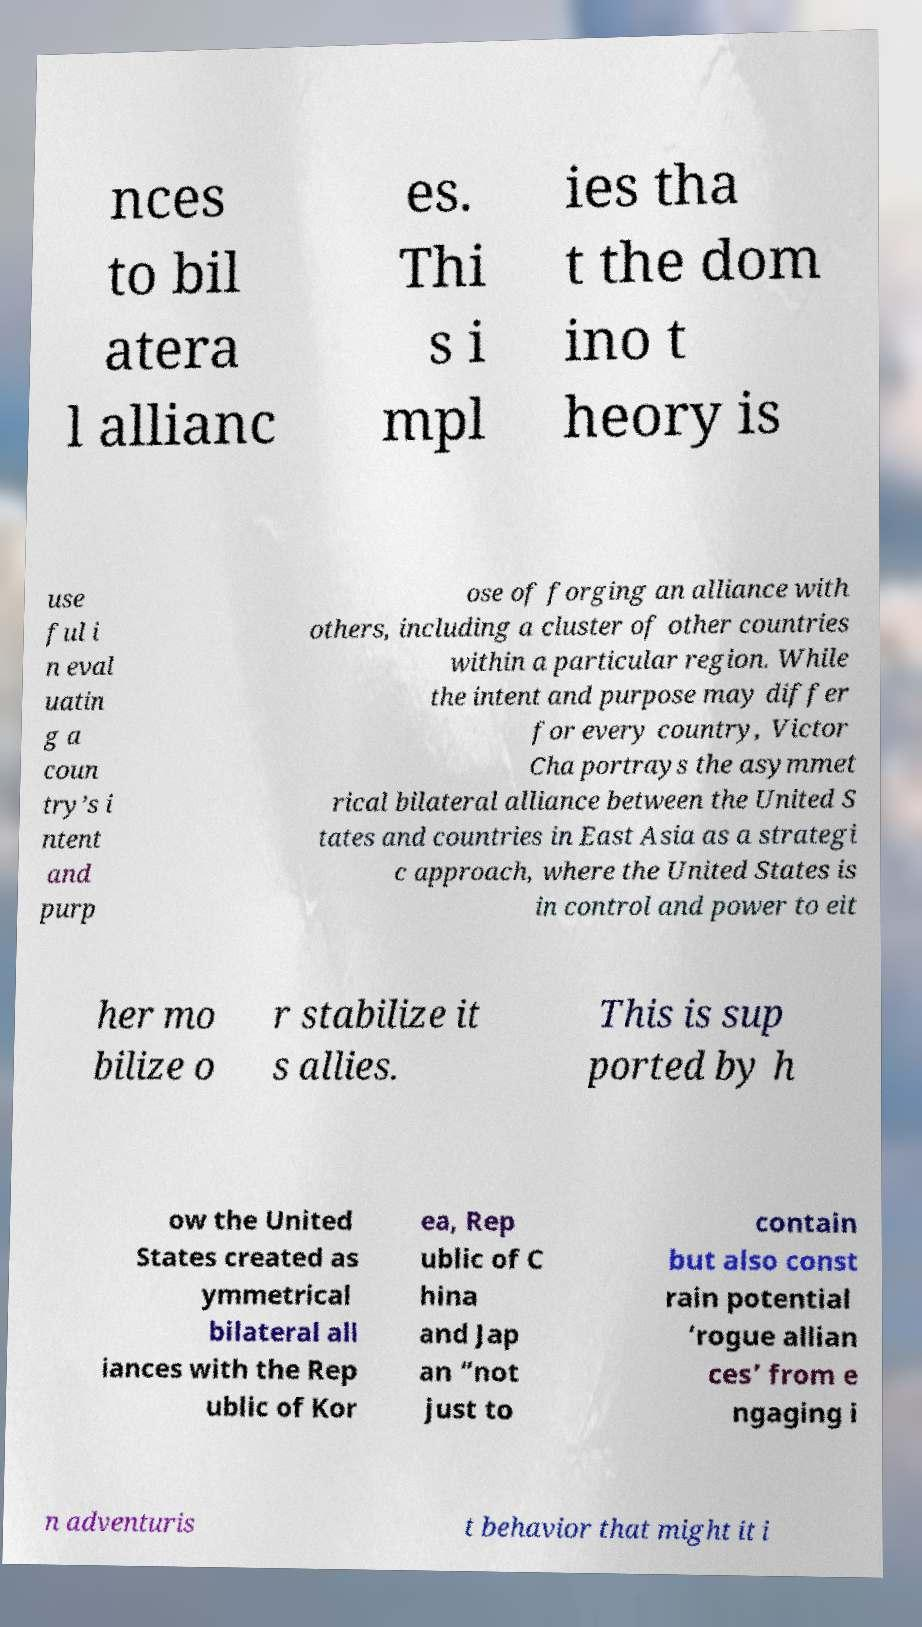For documentation purposes, I need the text within this image transcribed. Could you provide that? nces to bil atera l allianc es. Thi s i mpl ies tha t the dom ino t heory is use ful i n eval uatin g a coun try’s i ntent and purp ose of forging an alliance with others, including a cluster of other countries within a particular region. While the intent and purpose may differ for every country, Victor Cha portrays the asymmet rical bilateral alliance between the United S tates and countries in East Asia as a strategi c approach, where the United States is in control and power to eit her mo bilize o r stabilize it s allies. This is sup ported by h ow the United States created as ymmetrical bilateral all iances with the Rep ublic of Kor ea, Rep ublic of C hina and Jap an “not just to contain but also const rain potential ‘rogue allian ces’ from e ngaging i n adventuris t behavior that might it i 